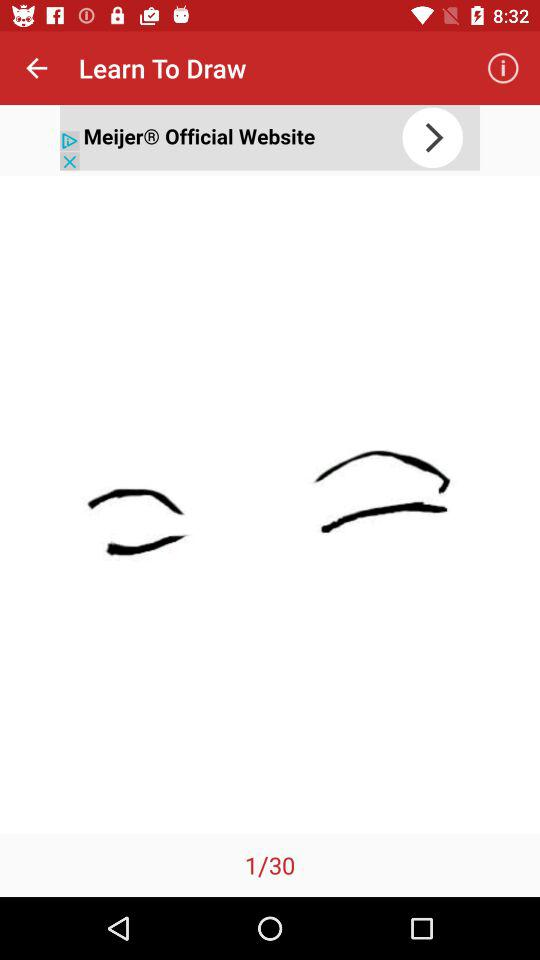Which image am I currently on? You are currently on image 1. 